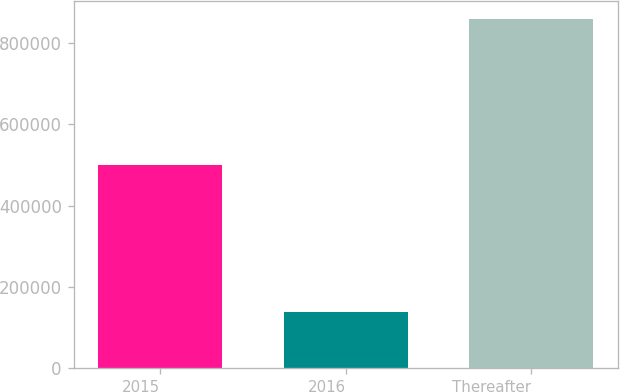<chart> <loc_0><loc_0><loc_500><loc_500><bar_chart><fcel>2015<fcel>2016<fcel>Thereafter<nl><fcel>500000<fcel>138000<fcel>860000<nl></chart> 